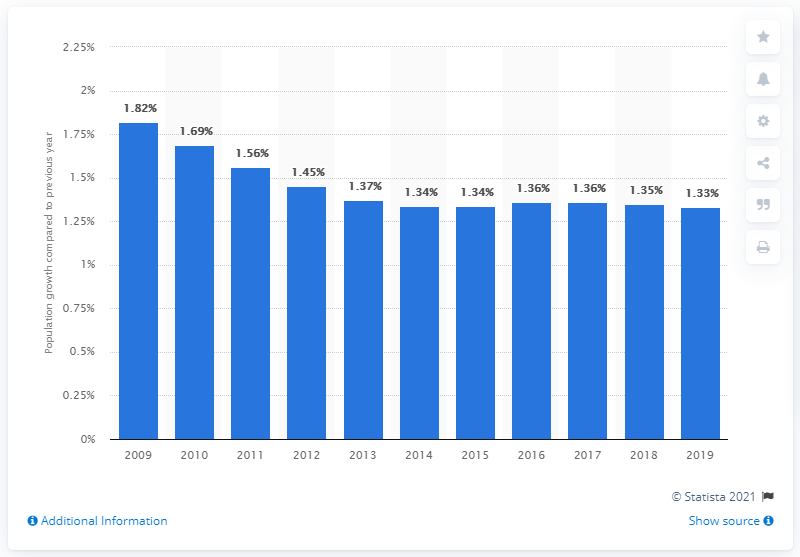Mention a couple of crucial points in this snapshot. According to the information available, the population of Malaysia increased by 1.33% in 2019. 